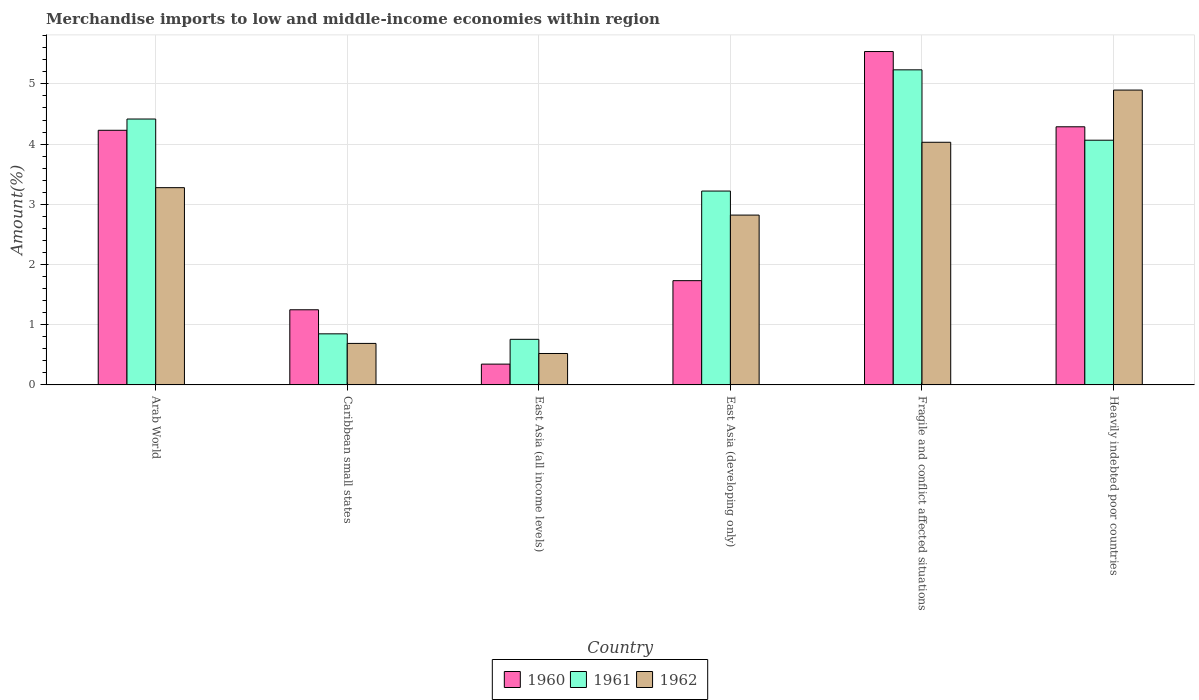How many groups of bars are there?
Offer a terse response. 6. How many bars are there on the 5th tick from the left?
Ensure brevity in your answer.  3. What is the label of the 2nd group of bars from the left?
Your answer should be very brief. Caribbean small states. In how many cases, is the number of bars for a given country not equal to the number of legend labels?
Provide a short and direct response. 0. What is the percentage of amount earned from merchandise imports in 1961 in Caribbean small states?
Offer a terse response. 0.85. Across all countries, what is the maximum percentage of amount earned from merchandise imports in 1962?
Your response must be concise. 4.9. Across all countries, what is the minimum percentage of amount earned from merchandise imports in 1960?
Offer a very short reply. 0.35. In which country was the percentage of amount earned from merchandise imports in 1960 maximum?
Provide a short and direct response. Fragile and conflict affected situations. In which country was the percentage of amount earned from merchandise imports in 1962 minimum?
Ensure brevity in your answer.  East Asia (all income levels). What is the total percentage of amount earned from merchandise imports in 1960 in the graph?
Offer a very short reply. 17.38. What is the difference between the percentage of amount earned from merchandise imports in 1961 in East Asia (all income levels) and that in Heavily indebted poor countries?
Provide a succinct answer. -3.31. What is the difference between the percentage of amount earned from merchandise imports in 1960 in Arab World and the percentage of amount earned from merchandise imports in 1962 in East Asia (developing only)?
Make the answer very short. 1.41. What is the average percentage of amount earned from merchandise imports in 1962 per country?
Provide a succinct answer. 2.71. What is the difference between the percentage of amount earned from merchandise imports of/in 1961 and percentage of amount earned from merchandise imports of/in 1960 in Heavily indebted poor countries?
Your answer should be compact. -0.22. In how many countries, is the percentage of amount earned from merchandise imports in 1961 greater than 2.4 %?
Your answer should be very brief. 4. What is the ratio of the percentage of amount earned from merchandise imports in 1962 in East Asia (developing only) to that in Fragile and conflict affected situations?
Give a very brief answer. 0.7. Is the difference between the percentage of amount earned from merchandise imports in 1961 in Caribbean small states and Fragile and conflict affected situations greater than the difference between the percentage of amount earned from merchandise imports in 1960 in Caribbean small states and Fragile and conflict affected situations?
Ensure brevity in your answer.  No. What is the difference between the highest and the second highest percentage of amount earned from merchandise imports in 1961?
Offer a terse response. -0.82. What is the difference between the highest and the lowest percentage of amount earned from merchandise imports in 1960?
Ensure brevity in your answer.  5.19. What does the 3rd bar from the left in East Asia (developing only) represents?
Your answer should be very brief. 1962. Is it the case that in every country, the sum of the percentage of amount earned from merchandise imports in 1961 and percentage of amount earned from merchandise imports in 1962 is greater than the percentage of amount earned from merchandise imports in 1960?
Offer a very short reply. Yes. How many bars are there?
Ensure brevity in your answer.  18. Are all the bars in the graph horizontal?
Offer a terse response. No. Does the graph contain any zero values?
Ensure brevity in your answer.  No. Where does the legend appear in the graph?
Ensure brevity in your answer.  Bottom center. How many legend labels are there?
Offer a terse response. 3. What is the title of the graph?
Keep it short and to the point. Merchandise imports to low and middle-income economies within region. Does "1996" appear as one of the legend labels in the graph?
Your answer should be compact. No. What is the label or title of the X-axis?
Offer a very short reply. Country. What is the label or title of the Y-axis?
Make the answer very short. Amount(%). What is the Amount(%) in 1960 in Arab World?
Your response must be concise. 4.23. What is the Amount(%) in 1961 in Arab World?
Ensure brevity in your answer.  4.42. What is the Amount(%) of 1962 in Arab World?
Provide a short and direct response. 3.28. What is the Amount(%) of 1960 in Caribbean small states?
Provide a short and direct response. 1.25. What is the Amount(%) in 1961 in Caribbean small states?
Make the answer very short. 0.85. What is the Amount(%) of 1962 in Caribbean small states?
Offer a very short reply. 0.69. What is the Amount(%) of 1960 in East Asia (all income levels)?
Your answer should be very brief. 0.35. What is the Amount(%) of 1961 in East Asia (all income levels)?
Offer a very short reply. 0.76. What is the Amount(%) of 1962 in East Asia (all income levels)?
Your response must be concise. 0.52. What is the Amount(%) in 1960 in East Asia (developing only)?
Make the answer very short. 1.73. What is the Amount(%) in 1961 in East Asia (developing only)?
Ensure brevity in your answer.  3.22. What is the Amount(%) in 1962 in East Asia (developing only)?
Provide a short and direct response. 2.82. What is the Amount(%) in 1960 in Fragile and conflict affected situations?
Provide a succinct answer. 5.54. What is the Amount(%) of 1961 in Fragile and conflict affected situations?
Offer a very short reply. 5.23. What is the Amount(%) in 1962 in Fragile and conflict affected situations?
Provide a succinct answer. 4.03. What is the Amount(%) of 1960 in Heavily indebted poor countries?
Give a very brief answer. 4.29. What is the Amount(%) in 1961 in Heavily indebted poor countries?
Your answer should be compact. 4.06. What is the Amount(%) of 1962 in Heavily indebted poor countries?
Provide a short and direct response. 4.9. Across all countries, what is the maximum Amount(%) of 1960?
Your answer should be very brief. 5.54. Across all countries, what is the maximum Amount(%) in 1961?
Offer a terse response. 5.23. Across all countries, what is the maximum Amount(%) of 1962?
Provide a short and direct response. 4.9. Across all countries, what is the minimum Amount(%) in 1960?
Your response must be concise. 0.35. Across all countries, what is the minimum Amount(%) of 1961?
Provide a short and direct response. 0.76. Across all countries, what is the minimum Amount(%) in 1962?
Offer a very short reply. 0.52. What is the total Amount(%) of 1960 in the graph?
Provide a short and direct response. 17.38. What is the total Amount(%) of 1961 in the graph?
Keep it short and to the point. 18.54. What is the total Amount(%) of 1962 in the graph?
Give a very brief answer. 16.24. What is the difference between the Amount(%) in 1960 in Arab World and that in Caribbean small states?
Offer a terse response. 2.98. What is the difference between the Amount(%) in 1961 in Arab World and that in Caribbean small states?
Your answer should be compact. 3.57. What is the difference between the Amount(%) in 1962 in Arab World and that in Caribbean small states?
Your response must be concise. 2.59. What is the difference between the Amount(%) of 1960 in Arab World and that in East Asia (all income levels)?
Your answer should be very brief. 3.88. What is the difference between the Amount(%) in 1961 in Arab World and that in East Asia (all income levels)?
Your answer should be very brief. 3.66. What is the difference between the Amount(%) of 1962 in Arab World and that in East Asia (all income levels)?
Your answer should be very brief. 2.75. What is the difference between the Amount(%) of 1960 in Arab World and that in East Asia (developing only)?
Your answer should be compact. 2.5. What is the difference between the Amount(%) of 1961 in Arab World and that in East Asia (developing only)?
Provide a succinct answer. 1.2. What is the difference between the Amount(%) in 1962 in Arab World and that in East Asia (developing only)?
Your answer should be compact. 0.46. What is the difference between the Amount(%) of 1960 in Arab World and that in Fragile and conflict affected situations?
Offer a terse response. -1.31. What is the difference between the Amount(%) of 1961 in Arab World and that in Fragile and conflict affected situations?
Your answer should be very brief. -0.82. What is the difference between the Amount(%) in 1962 in Arab World and that in Fragile and conflict affected situations?
Give a very brief answer. -0.75. What is the difference between the Amount(%) in 1960 in Arab World and that in Heavily indebted poor countries?
Your answer should be compact. -0.06. What is the difference between the Amount(%) of 1961 in Arab World and that in Heavily indebted poor countries?
Keep it short and to the point. 0.35. What is the difference between the Amount(%) of 1962 in Arab World and that in Heavily indebted poor countries?
Offer a terse response. -1.62. What is the difference between the Amount(%) in 1960 in Caribbean small states and that in East Asia (all income levels)?
Ensure brevity in your answer.  0.9. What is the difference between the Amount(%) in 1961 in Caribbean small states and that in East Asia (all income levels)?
Keep it short and to the point. 0.09. What is the difference between the Amount(%) of 1962 in Caribbean small states and that in East Asia (all income levels)?
Offer a very short reply. 0.17. What is the difference between the Amount(%) in 1960 in Caribbean small states and that in East Asia (developing only)?
Provide a succinct answer. -0.48. What is the difference between the Amount(%) of 1961 in Caribbean small states and that in East Asia (developing only)?
Ensure brevity in your answer.  -2.37. What is the difference between the Amount(%) in 1962 in Caribbean small states and that in East Asia (developing only)?
Your response must be concise. -2.13. What is the difference between the Amount(%) of 1960 in Caribbean small states and that in Fragile and conflict affected situations?
Give a very brief answer. -4.29. What is the difference between the Amount(%) in 1961 in Caribbean small states and that in Fragile and conflict affected situations?
Your answer should be compact. -4.39. What is the difference between the Amount(%) of 1962 in Caribbean small states and that in Fragile and conflict affected situations?
Give a very brief answer. -3.34. What is the difference between the Amount(%) of 1960 in Caribbean small states and that in Heavily indebted poor countries?
Keep it short and to the point. -3.04. What is the difference between the Amount(%) of 1961 in Caribbean small states and that in Heavily indebted poor countries?
Keep it short and to the point. -3.22. What is the difference between the Amount(%) in 1962 in Caribbean small states and that in Heavily indebted poor countries?
Offer a terse response. -4.21. What is the difference between the Amount(%) in 1960 in East Asia (all income levels) and that in East Asia (developing only)?
Your response must be concise. -1.39. What is the difference between the Amount(%) of 1961 in East Asia (all income levels) and that in East Asia (developing only)?
Offer a very short reply. -2.46. What is the difference between the Amount(%) of 1962 in East Asia (all income levels) and that in East Asia (developing only)?
Your answer should be compact. -2.3. What is the difference between the Amount(%) in 1960 in East Asia (all income levels) and that in Fragile and conflict affected situations?
Offer a terse response. -5.19. What is the difference between the Amount(%) of 1961 in East Asia (all income levels) and that in Fragile and conflict affected situations?
Your answer should be very brief. -4.48. What is the difference between the Amount(%) in 1962 in East Asia (all income levels) and that in Fragile and conflict affected situations?
Offer a terse response. -3.51. What is the difference between the Amount(%) in 1960 in East Asia (all income levels) and that in Heavily indebted poor countries?
Keep it short and to the point. -3.94. What is the difference between the Amount(%) in 1961 in East Asia (all income levels) and that in Heavily indebted poor countries?
Ensure brevity in your answer.  -3.31. What is the difference between the Amount(%) in 1962 in East Asia (all income levels) and that in Heavily indebted poor countries?
Your response must be concise. -4.38. What is the difference between the Amount(%) of 1960 in East Asia (developing only) and that in Fragile and conflict affected situations?
Provide a short and direct response. -3.81. What is the difference between the Amount(%) of 1961 in East Asia (developing only) and that in Fragile and conflict affected situations?
Offer a terse response. -2.01. What is the difference between the Amount(%) in 1962 in East Asia (developing only) and that in Fragile and conflict affected situations?
Your answer should be very brief. -1.21. What is the difference between the Amount(%) of 1960 in East Asia (developing only) and that in Heavily indebted poor countries?
Your answer should be very brief. -2.56. What is the difference between the Amount(%) in 1961 in East Asia (developing only) and that in Heavily indebted poor countries?
Provide a succinct answer. -0.84. What is the difference between the Amount(%) of 1962 in East Asia (developing only) and that in Heavily indebted poor countries?
Provide a short and direct response. -2.08. What is the difference between the Amount(%) in 1961 in Fragile and conflict affected situations and that in Heavily indebted poor countries?
Give a very brief answer. 1.17. What is the difference between the Amount(%) of 1962 in Fragile and conflict affected situations and that in Heavily indebted poor countries?
Offer a terse response. -0.87. What is the difference between the Amount(%) of 1960 in Arab World and the Amount(%) of 1961 in Caribbean small states?
Ensure brevity in your answer.  3.38. What is the difference between the Amount(%) in 1960 in Arab World and the Amount(%) in 1962 in Caribbean small states?
Your answer should be compact. 3.54. What is the difference between the Amount(%) of 1961 in Arab World and the Amount(%) of 1962 in Caribbean small states?
Your answer should be compact. 3.73. What is the difference between the Amount(%) of 1960 in Arab World and the Amount(%) of 1961 in East Asia (all income levels)?
Offer a very short reply. 3.47. What is the difference between the Amount(%) in 1960 in Arab World and the Amount(%) in 1962 in East Asia (all income levels)?
Provide a short and direct response. 3.71. What is the difference between the Amount(%) in 1961 in Arab World and the Amount(%) in 1962 in East Asia (all income levels)?
Your answer should be very brief. 3.89. What is the difference between the Amount(%) in 1960 in Arab World and the Amount(%) in 1961 in East Asia (developing only)?
Offer a terse response. 1.01. What is the difference between the Amount(%) in 1960 in Arab World and the Amount(%) in 1962 in East Asia (developing only)?
Give a very brief answer. 1.41. What is the difference between the Amount(%) in 1961 in Arab World and the Amount(%) in 1962 in East Asia (developing only)?
Provide a short and direct response. 1.6. What is the difference between the Amount(%) in 1960 in Arab World and the Amount(%) in 1961 in Fragile and conflict affected situations?
Give a very brief answer. -1. What is the difference between the Amount(%) in 1960 in Arab World and the Amount(%) in 1962 in Fragile and conflict affected situations?
Provide a short and direct response. 0.2. What is the difference between the Amount(%) in 1961 in Arab World and the Amount(%) in 1962 in Fragile and conflict affected situations?
Provide a short and direct response. 0.39. What is the difference between the Amount(%) of 1960 in Arab World and the Amount(%) of 1961 in Heavily indebted poor countries?
Provide a short and direct response. 0.16. What is the difference between the Amount(%) in 1960 in Arab World and the Amount(%) in 1962 in Heavily indebted poor countries?
Give a very brief answer. -0.67. What is the difference between the Amount(%) of 1961 in Arab World and the Amount(%) of 1962 in Heavily indebted poor countries?
Provide a short and direct response. -0.48. What is the difference between the Amount(%) of 1960 in Caribbean small states and the Amount(%) of 1961 in East Asia (all income levels)?
Keep it short and to the point. 0.49. What is the difference between the Amount(%) in 1960 in Caribbean small states and the Amount(%) in 1962 in East Asia (all income levels)?
Your response must be concise. 0.73. What is the difference between the Amount(%) in 1961 in Caribbean small states and the Amount(%) in 1962 in East Asia (all income levels)?
Offer a very short reply. 0.33. What is the difference between the Amount(%) of 1960 in Caribbean small states and the Amount(%) of 1961 in East Asia (developing only)?
Keep it short and to the point. -1.97. What is the difference between the Amount(%) of 1960 in Caribbean small states and the Amount(%) of 1962 in East Asia (developing only)?
Make the answer very short. -1.57. What is the difference between the Amount(%) in 1961 in Caribbean small states and the Amount(%) in 1962 in East Asia (developing only)?
Keep it short and to the point. -1.97. What is the difference between the Amount(%) of 1960 in Caribbean small states and the Amount(%) of 1961 in Fragile and conflict affected situations?
Keep it short and to the point. -3.99. What is the difference between the Amount(%) in 1960 in Caribbean small states and the Amount(%) in 1962 in Fragile and conflict affected situations?
Your response must be concise. -2.78. What is the difference between the Amount(%) of 1961 in Caribbean small states and the Amount(%) of 1962 in Fragile and conflict affected situations?
Provide a short and direct response. -3.18. What is the difference between the Amount(%) of 1960 in Caribbean small states and the Amount(%) of 1961 in Heavily indebted poor countries?
Offer a terse response. -2.82. What is the difference between the Amount(%) of 1960 in Caribbean small states and the Amount(%) of 1962 in Heavily indebted poor countries?
Your answer should be compact. -3.65. What is the difference between the Amount(%) of 1961 in Caribbean small states and the Amount(%) of 1962 in Heavily indebted poor countries?
Make the answer very short. -4.05. What is the difference between the Amount(%) in 1960 in East Asia (all income levels) and the Amount(%) in 1961 in East Asia (developing only)?
Make the answer very short. -2.87. What is the difference between the Amount(%) in 1960 in East Asia (all income levels) and the Amount(%) in 1962 in East Asia (developing only)?
Give a very brief answer. -2.48. What is the difference between the Amount(%) of 1961 in East Asia (all income levels) and the Amount(%) of 1962 in East Asia (developing only)?
Offer a very short reply. -2.06. What is the difference between the Amount(%) of 1960 in East Asia (all income levels) and the Amount(%) of 1961 in Fragile and conflict affected situations?
Your answer should be very brief. -4.89. What is the difference between the Amount(%) of 1960 in East Asia (all income levels) and the Amount(%) of 1962 in Fragile and conflict affected situations?
Your response must be concise. -3.69. What is the difference between the Amount(%) of 1961 in East Asia (all income levels) and the Amount(%) of 1962 in Fragile and conflict affected situations?
Offer a very short reply. -3.27. What is the difference between the Amount(%) in 1960 in East Asia (all income levels) and the Amount(%) in 1961 in Heavily indebted poor countries?
Keep it short and to the point. -3.72. What is the difference between the Amount(%) in 1960 in East Asia (all income levels) and the Amount(%) in 1962 in Heavily indebted poor countries?
Your answer should be very brief. -4.55. What is the difference between the Amount(%) of 1961 in East Asia (all income levels) and the Amount(%) of 1962 in Heavily indebted poor countries?
Keep it short and to the point. -4.14. What is the difference between the Amount(%) in 1960 in East Asia (developing only) and the Amount(%) in 1961 in Fragile and conflict affected situations?
Your response must be concise. -3.5. What is the difference between the Amount(%) in 1960 in East Asia (developing only) and the Amount(%) in 1962 in Fragile and conflict affected situations?
Provide a succinct answer. -2.3. What is the difference between the Amount(%) of 1961 in East Asia (developing only) and the Amount(%) of 1962 in Fragile and conflict affected situations?
Offer a very short reply. -0.81. What is the difference between the Amount(%) of 1960 in East Asia (developing only) and the Amount(%) of 1961 in Heavily indebted poor countries?
Provide a short and direct response. -2.33. What is the difference between the Amount(%) of 1960 in East Asia (developing only) and the Amount(%) of 1962 in Heavily indebted poor countries?
Your answer should be very brief. -3.17. What is the difference between the Amount(%) of 1961 in East Asia (developing only) and the Amount(%) of 1962 in Heavily indebted poor countries?
Ensure brevity in your answer.  -1.68. What is the difference between the Amount(%) in 1960 in Fragile and conflict affected situations and the Amount(%) in 1961 in Heavily indebted poor countries?
Your answer should be compact. 1.47. What is the difference between the Amount(%) of 1960 in Fragile and conflict affected situations and the Amount(%) of 1962 in Heavily indebted poor countries?
Make the answer very short. 0.64. What is the difference between the Amount(%) in 1961 in Fragile and conflict affected situations and the Amount(%) in 1962 in Heavily indebted poor countries?
Offer a terse response. 0.34. What is the average Amount(%) in 1960 per country?
Provide a short and direct response. 2.9. What is the average Amount(%) of 1961 per country?
Provide a short and direct response. 3.09. What is the average Amount(%) of 1962 per country?
Keep it short and to the point. 2.71. What is the difference between the Amount(%) of 1960 and Amount(%) of 1961 in Arab World?
Make the answer very short. -0.19. What is the difference between the Amount(%) in 1960 and Amount(%) in 1962 in Arab World?
Provide a succinct answer. 0.95. What is the difference between the Amount(%) in 1961 and Amount(%) in 1962 in Arab World?
Offer a very short reply. 1.14. What is the difference between the Amount(%) in 1960 and Amount(%) in 1961 in Caribbean small states?
Provide a short and direct response. 0.4. What is the difference between the Amount(%) of 1960 and Amount(%) of 1962 in Caribbean small states?
Keep it short and to the point. 0.56. What is the difference between the Amount(%) of 1961 and Amount(%) of 1962 in Caribbean small states?
Your answer should be very brief. 0.16. What is the difference between the Amount(%) in 1960 and Amount(%) in 1961 in East Asia (all income levels)?
Your answer should be very brief. -0.41. What is the difference between the Amount(%) in 1960 and Amount(%) in 1962 in East Asia (all income levels)?
Provide a succinct answer. -0.18. What is the difference between the Amount(%) of 1961 and Amount(%) of 1962 in East Asia (all income levels)?
Ensure brevity in your answer.  0.24. What is the difference between the Amount(%) of 1960 and Amount(%) of 1961 in East Asia (developing only)?
Your answer should be compact. -1.49. What is the difference between the Amount(%) in 1960 and Amount(%) in 1962 in East Asia (developing only)?
Give a very brief answer. -1.09. What is the difference between the Amount(%) in 1961 and Amount(%) in 1962 in East Asia (developing only)?
Your answer should be compact. 0.4. What is the difference between the Amount(%) in 1960 and Amount(%) in 1961 in Fragile and conflict affected situations?
Your answer should be very brief. 0.3. What is the difference between the Amount(%) of 1960 and Amount(%) of 1962 in Fragile and conflict affected situations?
Your response must be concise. 1.51. What is the difference between the Amount(%) in 1961 and Amount(%) in 1962 in Fragile and conflict affected situations?
Your answer should be very brief. 1.2. What is the difference between the Amount(%) in 1960 and Amount(%) in 1961 in Heavily indebted poor countries?
Your response must be concise. 0.22. What is the difference between the Amount(%) in 1960 and Amount(%) in 1962 in Heavily indebted poor countries?
Your answer should be compact. -0.61. What is the difference between the Amount(%) in 1961 and Amount(%) in 1962 in Heavily indebted poor countries?
Your answer should be very brief. -0.83. What is the ratio of the Amount(%) of 1960 in Arab World to that in Caribbean small states?
Your answer should be compact. 3.39. What is the ratio of the Amount(%) of 1961 in Arab World to that in Caribbean small states?
Keep it short and to the point. 5.21. What is the ratio of the Amount(%) of 1962 in Arab World to that in Caribbean small states?
Your answer should be compact. 4.75. What is the ratio of the Amount(%) of 1960 in Arab World to that in East Asia (all income levels)?
Make the answer very short. 12.24. What is the ratio of the Amount(%) in 1961 in Arab World to that in East Asia (all income levels)?
Your answer should be very brief. 5.83. What is the ratio of the Amount(%) of 1962 in Arab World to that in East Asia (all income levels)?
Give a very brief answer. 6.28. What is the ratio of the Amount(%) in 1960 in Arab World to that in East Asia (developing only)?
Give a very brief answer. 2.44. What is the ratio of the Amount(%) of 1961 in Arab World to that in East Asia (developing only)?
Ensure brevity in your answer.  1.37. What is the ratio of the Amount(%) of 1962 in Arab World to that in East Asia (developing only)?
Offer a terse response. 1.16. What is the ratio of the Amount(%) in 1960 in Arab World to that in Fragile and conflict affected situations?
Provide a succinct answer. 0.76. What is the ratio of the Amount(%) in 1961 in Arab World to that in Fragile and conflict affected situations?
Make the answer very short. 0.84. What is the ratio of the Amount(%) in 1962 in Arab World to that in Fragile and conflict affected situations?
Offer a terse response. 0.81. What is the ratio of the Amount(%) in 1960 in Arab World to that in Heavily indebted poor countries?
Make the answer very short. 0.99. What is the ratio of the Amount(%) in 1961 in Arab World to that in Heavily indebted poor countries?
Ensure brevity in your answer.  1.09. What is the ratio of the Amount(%) of 1962 in Arab World to that in Heavily indebted poor countries?
Offer a terse response. 0.67. What is the ratio of the Amount(%) of 1960 in Caribbean small states to that in East Asia (all income levels)?
Your answer should be compact. 3.61. What is the ratio of the Amount(%) in 1961 in Caribbean small states to that in East Asia (all income levels)?
Make the answer very short. 1.12. What is the ratio of the Amount(%) in 1962 in Caribbean small states to that in East Asia (all income levels)?
Offer a terse response. 1.32. What is the ratio of the Amount(%) of 1960 in Caribbean small states to that in East Asia (developing only)?
Your answer should be compact. 0.72. What is the ratio of the Amount(%) in 1961 in Caribbean small states to that in East Asia (developing only)?
Offer a terse response. 0.26. What is the ratio of the Amount(%) of 1962 in Caribbean small states to that in East Asia (developing only)?
Your answer should be compact. 0.24. What is the ratio of the Amount(%) in 1960 in Caribbean small states to that in Fragile and conflict affected situations?
Keep it short and to the point. 0.23. What is the ratio of the Amount(%) in 1961 in Caribbean small states to that in Fragile and conflict affected situations?
Make the answer very short. 0.16. What is the ratio of the Amount(%) in 1962 in Caribbean small states to that in Fragile and conflict affected situations?
Your answer should be compact. 0.17. What is the ratio of the Amount(%) in 1960 in Caribbean small states to that in Heavily indebted poor countries?
Your response must be concise. 0.29. What is the ratio of the Amount(%) in 1961 in Caribbean small states to that in Heavily indebted poor countries?
Your answer should be compact. 0.21. What is the ratio of the Amount(%) of 1962 in Caribbean small states to that in Heavily indebted poor countries?
Your answer should be very brief. 0.14. What is the ratio of the Amount(%) in 1960 in East Asia (all income levels) to that in East Asia (developing only)?
Give a very brief answer. 0.2. What is the ratio of the Amount(%) of 1961 in East Asia (all income levels) to that in East Asia (developing only)?
Provide a succinct answer. 0.24. What is the ratio of the Amount(%) in 1962 in East Asia (all income levels) to that in East Asia (developing only)?
Offer a terse response. 0.18. What is the ratio of the Amount(%) in 1960 in East Asia (all income levels) to that in Fragile and conflict affected situations?
Keep it short and to the point. 0.06. What is the ratio of the Amount(%) of 1961 in East Asia (all income levels) to that in Fragile and conflict affected situations?
Provide a short and direct response. 0.14. What is the ratio of the Amount(%) in 1962 in East Asia (all income levels) to that in Fragile and conflict affected situations?
Make the answer very short. 0.13. What is the ratio of the Amount(%) of 1960 in East Asia (all income levels) to that in Heavily indebted poor countries?
Your answer should be very brief. 0.08. What is the ratio of the Amount(%) of 1961 in East Asia (all income levels) to that in Heavily indebted poor countries?
Ensure brevity in your answer.  0.19. What is the ratio of the Amount(%) in 1962 in East Asia (all income levels) to that in Heavily indebted poor countries?
Offer a very short reply. 0.11. What is the ratio of the Amount(%) in 1960 in East Asia (developing only) to that in Fragile and conflict affected situations?
Your answer should be compact. 0.31. What is the ratio of the Amount(%) in 1961 in East Asia (developing only) to that in Fragile and conflict affected situations?
Offer a terse response. 0.62. What is the ratio of the Amount(%) in 1962 in East Asia (developing only) to that in Fragile and conflict affected situations?
Offer a very short reply. 0.7. What is the ratio of the Amount(%) in 1960 in East Asia (developing only) to that in Heavily indebted poor countries?
Provide a succinct answer. 0.4. What is the ratio of the Amount(%) in 1961 in East Asia (developing only) to that in Heavily indebted poor countries?
Offer a terse response. 0.79. What is the ratio of the Amount(%) in 1962 in East Asia (developing only) to that in Heavily indebted poor countries?
Give a very brief answer. 0.58. What is the ratio of the Amount(%) in 1960 in Fragile and conflict affected situations to that in Heavily indebted poor countries?
Provide a short and direct response. 1.29. What is the ratio of the Amount(%) in 1961 in Fragile and conflict affected situations to that in Heavily indebted poor countries?
Offer a very short reply. 1.29. What is the ratio of the Amount(%) in 1962 in Fragile and conflict affected situations to that in Heavily indebted poor countries?
Offer a terse response. 0.82. What is the difference between the highest and the second highest Amount(%) of 1960?
Make the answer very short. 1.25. What is the difference between the highest and the second highest Amount(%) in 1961?
Make the answer very short. 0.82. What is the difference between the highest and the second highest Amount(%) of 1962?
Provide a short and direct response. 0.87. What is the difference between the highest and the lowest Amount(%) in 1960?
Your answer should be very brief. 5.19. What is the difference between the highest and the lowest Amount(%) of 1961?
Your response must be concise. 4.48. What is the difference between the highest and the lowest Amount(%) in 1962?
Ensure brevity in your answer.  4.38. 